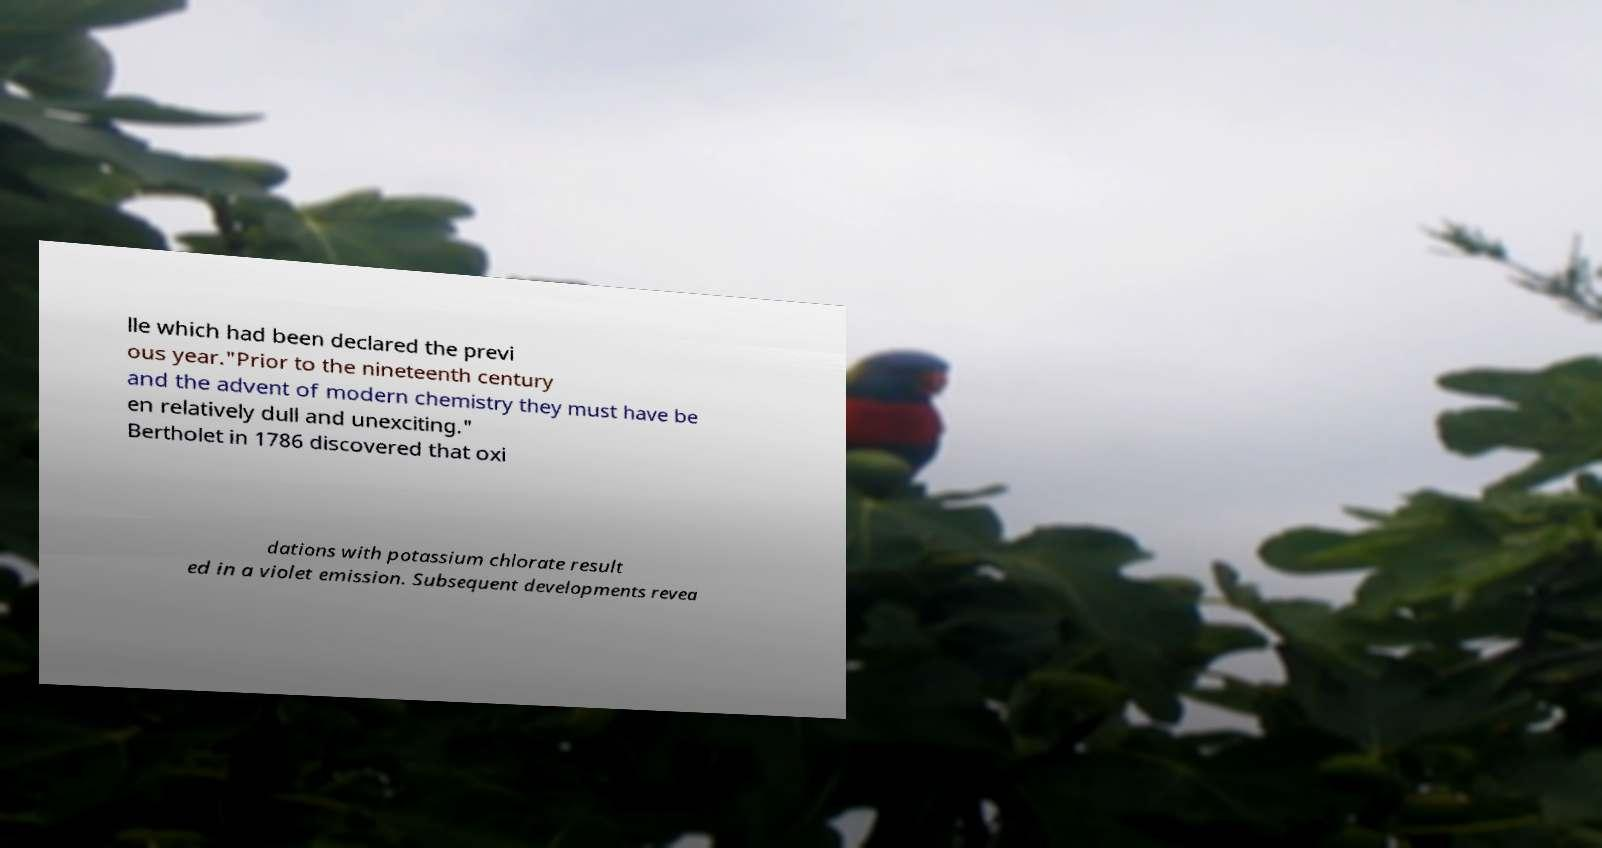Can you accurately transcribe the text from the provided image for me? lle which had been declared the previ ous year."Prior to the nineteenth century and the advent of modern chemistry they must have be en relatively dull and unexciting." Bertholet in 1786 discovered that oxi dations with potassium chlorate result ed in a violet emission. Subsequent developments revea 